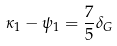Convert formula to latex. <formula><loc_0><loc_0><loc_500><loc_500>\kappa _ { 1 } - \psi _ { 1 } = \frac { 7 } { 5 } \delta _ { G }</formula> 